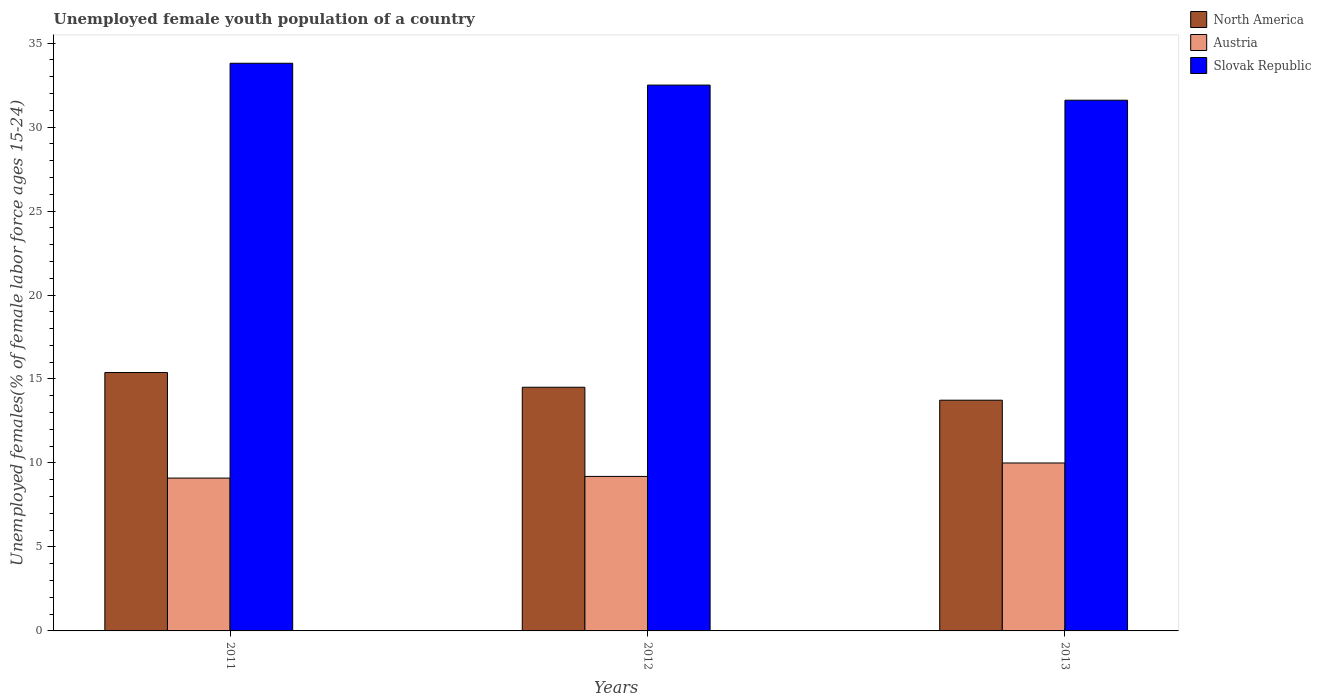How many bars are there on the 3rd tick from the right?
Make the answer very short. 3. What is the label of the 2nd group of bars from the left?
Your answer should be very brief. 2012. In how many cases, is the number of bars for a given year not equal to the number of legend labels?
Offer a very short reply. 0. What is the percentage of unemployed female youth population in Austria in 2013?
Your answer should be very brief. 10. Across all years, what is the maximum percentage of unemployed female youth population in North America?
Provide a short and direct response. 15.39. Across all years, what is the minimum percentage of unemployed female youth population in Austria?
Provide a short and direct response. 9.1. In which year was the percentage of unemployed female youth population in North America minimum?
Provide a short and direct response. 2013. What is the total percentage of unemployed female youth population in Austria in the graph?
Keep it short and to the point. 28.3. What is the difference between the percentage of unemployed female youth population in Slovak Republic in 2011 and that in 2013?
Offer a terse response. 2.2. What is the difference between the percentage of unemployed female youth population in Austria in 2012 and the percentage of unemployed female youth population in Slovak Republic in 2013?
Make the answer very short. -22.4. What is the average percentage of unemployed female youth population in Austria per year?
Keep it short and to the point. 9.43. In the year 2011, what is the difference between the percentage of unemployed female youth population in North America and percentage of unemployed female youth population in Slovak Republic?
Your response must be concise. -18.41. What is the ratio of the percentage of unemployed female youth population in Slovak Republic in 2011 to that in 2012?
Keep it short and to the point. 1.04. Is the difference between the percentage of unemployed female youth population in North America in 2011 and 2012 greater than the difference between the percentage of unemployed female youth population in Slovak Republic in 2011 and 2012?
Your answer should be compact. No. What is the difference between the highest and the second highest percentage of unemployed female youth population in North America?
Provide a short and direct response. 0.88. What is the difference between the highest and the lowest percentage of unemployed female youth population in North America?
Your answer should be compact. 1.65. In how many years, is the percentage of unemployed female youth population in Austria greater than the average percentage of unemployed female youth population in Austria taken over all years?
Offer a terse response. 1. How many bars are there?
Your response must be concise. 9. How many years are there in the graph?
Ensure brevity in your answer.  3. What is the difference between two consecutive major ticks on the Y-axis?
Make the answer very short. 5. What is the title of the graph?
Provide a short and direct response. Unemployed female youth population of a country. Does "Cambodia" appear as one of the legend labels in the graph?
Provide a short and direct response. No. What is the label or title of the X-axis?
Offer a very short reply. Years. What is the label or title of the Y-axis?
Make the answer very short. Unemployed females(% of female labor force ages 15-24). What is the Unemployed females(% of female labor force ages 15-24) in North America in 2011?
Provide a succinct answer. 15.39. What is the Unemployed females(% of female labor force ages 15-24) of Austria in 2011?
Your answer should be very brief. 9.1. What is the Unemployed females(% of female labor force ages 15-24) in Slovak Republic in 2011?
Your answer should be compact. 33.8. What is the Unemployed females(% of female labor force ages 15-24) in North America in 2012?
Offer a very short reply. 14.51. What is the Unemployed females(% of female labor force ages 15-24) in Austria in 2012?
Your answer should be very brief. 9.2. What is the Unemployed females(% of female labor force ages 15-24) of Slovak Republic in 2012?
Give a very brief answer. 32.5. What is the Unemployed females(% of female labor force ages 15-24) of North America in 2013?
Give a very brief answer. 13.74. What is the Unemployed females(% of female labor force ages 15-24) of Austria in 2013?
Ensure brevity in your answer.  10. What is the Unemployed females(% of female labor force ages 15-24) in Slovak Republic in 2013?
Offer a terse response. 31.6. Across all years, what is the maximum Unemployed females(% of female labor force ages 15-24) of North America?
Your answer should be compact. 15.39. Across all years, what is the maximum Unemployed females(% of female labor force ages 15-24) of Slovak Republic?
Offer a terse response. 33.8. Across all years, what is the minimum Unemployed females(% of female labor force ages 15-24) of North America?
Provide a succinct answer. 13.74. Across all years, what is the minimum Unemployed females(% of female labor force ages 15-24) in Austria?
Offer a very short reply. 9.1. Across all years, what is the minimum Unemployed females(% of female labor force ages 15-24) in Slovak Republic?
Your response must be concise. 31.6. What is the total Unemployed females(% of female labor force ages 15-24) in North America in the graph?
Make the answer very short. 43.63. What is the total Unemployed females(% of female labor force ages 15-24) of Austria in the graph?
Keep it short and to the point. 28.3. What is the total Unemployed females(% of female labor force ages 15-24) of Slovak Republic in the graph?
Offer a very short reply. 97.9. What is the difference between the Unemployed females(% of female labor force ages 15-24) of North America in 2011 and that in 2012?
Offer a very short reply. 0.88. What is the difference between the Unemployed females(% of female labor force ages 15-24) in North America in 2011 and that in 2013?
Give a very brief answer. 1.65. What is the difference between the Unemployed females(% of female labor force ages 15-24) of Austria in 2011 and that in 2013?
Give a very brief answer. -0.9. What is the difference between the Unemployed females(% of female labor force ages 15-24) of North America in 2012 and that in 2013?
Your answer should be very brief. 0.77. What is the difference between the Unemployed females(% of female labor force ages 15-24) of Slovak Republic in 2012 and that in 2013?
Offer a terse response. 0.9. What is the difference between the Unemployed females(% of female labor force ages 15-24) in North America in 2011 and the Unemployed females(% of female labor force ages 15-24) in Austria in 2012?
Your response must be concise. 6.19. What is the difference between the Unemployed females(% of female labor force ages 15-24) of North America in 2011 and the Unemployed females(% of female labor force ages 15-24) of Slovak Republic in 2012?
Provide a short and direct response. -17.11. What is the difference between the Unemployed females(% of female labor force ages 15-24) in Austria in 2011 and the Unemployed females(% of female labor force ages 15-24) in Slovak Republic in 2012?
Your answer should be compact. -23.4. What is the difference between the Unemployed females(% of female labor force ages 15-24) in North America in 2011 and the Unemployed females(% of female labor force ages 15-24) in Austria in 2013?
Your answer should be compact. 5.39. What is the difference between the Unemployed females(% of female labor force ages 15-24) in North America in 2011 and the Unemployed females(% of female labor force ages 15-24) in Slovak Republic in 2013?
Offer a terse response. -16.21. What is the difference between the Unemployed females(% of female labor force ages 15-24) of Austria in 2011 and the Unemployed females(% of female labor force ages 15-24) of Slovak Republic in 2013?
Provide a succinct answer. -22.5. What is the difference between the Unemployed females(% of female labor force ages 15-24) in North America in 2012 and the Unemployed females(% of female labor force ages 15-24) in Austria in 2013?
Offer a terse response. 4.51. What is the difference between the Unemployed females(% of female labor force ages 15-24) in North America in 2012 and the Unemployed females(% of female labor force ages 15-24) in Slovak Republic in 2013?
Ensure brevity in your answer.  -17.09. What is the difference between the Unemployed females(% of female labor force ages 15-24) in Austria in 2012 and the Unemployed females(% of female labor force ages 15-24) in Slovak Republic in 2013?
Your response must be concise. -22.4. What is the average Unemployed females(% of female labor force ages 15-24) in North America per year?
Give a very brief answer. 14.54. What is the average Unemployed females(% of female labor force ages 15-24) in Austria per year?
Your answer should be very brief. 9.43. What is the average Unemployed females(% of female labor force ages 15-24) in Slovak Republic per year?
Provide a succinct answer. 32.63. In the year 2011, what is the difference between the Unemployed females(% of female labor force ages 15-24) in North America and Unemployed females(% of female labor force ages 15-24) in Austria?
Provide a short and direct response. 6.29. In the year 2011, what is the difference between the Unemployed females(% of female labor force ages 15-24) of North America and Unemployed females(% of female labor force ages 15-24) of Slovak Republic?
Offer a very short reply. -18.41. In the year 2011, what is the difference between the Unemployed females(% of female labor force ages 15-24) of Austria and Unemployed females(% of female labor force ages 15-24) of Slovak Republic?
Your answer should be very brief. -24.7. In the year 2012, what is the difference between the Unemployed females(% of female labor force ages 15-24) in North America and Unemployed females(% of female labor force ages 15-24) in Austria?
Your answer should be compact. 5.31. In the year 2012, what is the difference between the Unemployed females(% of female labor force ages 15-24) in North America and Unemployed females(% of female labor force ages 15-24) in Slovak Republic?
Offer a very short reply. -17.99. In the year 2012, what is the difference between the Unemployed females(% of female labor force ages 15-24) of Austria and Unemployed females(% of female labor force ages 15-24) of Slovak Republic?
Your response must be concise. -23.3. In the year 2013, what is the difference between the Unemployed females(% of female labor force ages 15-24) of North America and Unemployed females(% of female labor force ages 15-24) of Austria?
Provide a succinct answer. 3.74. In the year 2013, what is the difference between the Unemployed females(% of female labor force ages 15-24) of North America and Unemployed females(% of female labor force ages 15-24) of Slovak Republic?
Provide a short and direct response. -17.86. In the year 2013, what is the difference between the Unemployed females(% of female labor force ages 15-24) in Austria and Unemployed females(% of female labor force ages 15-24) in Slovak Republic?
Offer a terse response. -21.6. What is the ratio of the Unemployed females(% of female labor force ages 15-24) of North America in 2011 to that in 2012?
Your answer should be compact. 1.06. What is the ratio of the Unemployed females(% of female labor force ages 15-24) of Austria in 2011 to that in 2012?
Your response must be concise. 0.99. What is the ratio of the Unemployed females(% of female labor force ages 15-24) in Slovak Republic in 2011 to that in 2012?
Offer a terse response. 1.04. What is the ratio of the Unemployed females(% of female labor force ages 15-24) of North America in 2011 to that in 2013?
Provide a succinct answer. 1.12. What is the ratio of the Unemployed females(% of female labor force ages 15-24) in Austria in 2011 to that in 2013?
Offer a very short reply. 0.91. What is the ratio of the Unemployed females(% of female labor force ages 15-24) of Slovak Republic in 2011 to that in 2013?
Ensure brevity in your answer.  1.07. What is the ratio of the Unemployed females(% of female labor force ages 15-24) of North America in 2012 to that in 2013?
Keep it short and to the point. 1.06. What is the ratio of the Unemployed females(% of female labor force ages 15-24) of Austria in 2012 to that in 2013?
Provide a succinct answer. 0.92. What is the ratio of the Unemployed females(% of female labor force ages 15-24) in Slovak Republic in 2012 to that in 2013?
Provide a succinct answer. 1.03. What is the difference between the highest and the second highest Unemployed females(% of female labor force ages 15-24) of North America?
Your response must be concise. 0.88. What is the difference between the highest and the lowest Unemployed females(% of female labor force ages 15-24) in North America?
Your answer should be very brief. 1.65. 